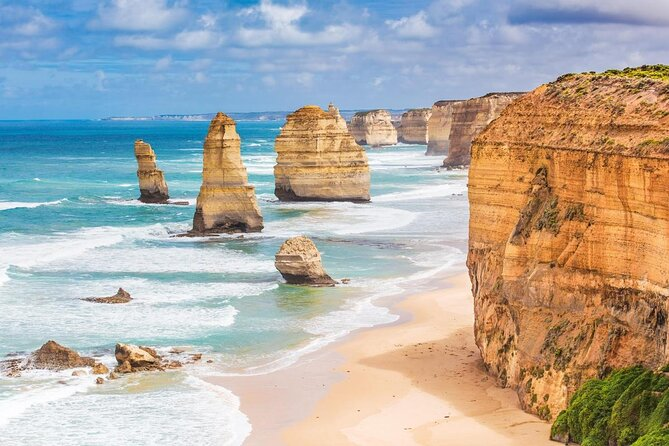Describe the Twelve Apostles and their geological significance. The Twelve Apostles are a series of towering limestone stacks along the coast of Victoria, Australia. Formed by erosion over millions of years, these formations are the remnants of ancient cliffs that have been worn down by harsh weather conditions and the relentless sea. Each stack is made up of layers of limestone, sedimentary rock that originated from the accumulation of marine organisms' skeletal remains. These formations not only represent stunning natural beauty but also offer rich insights into the region's geological history. The varying heights and shapes of the stacks provide a visual record of the ongoing natural forces shaping the coastline. 